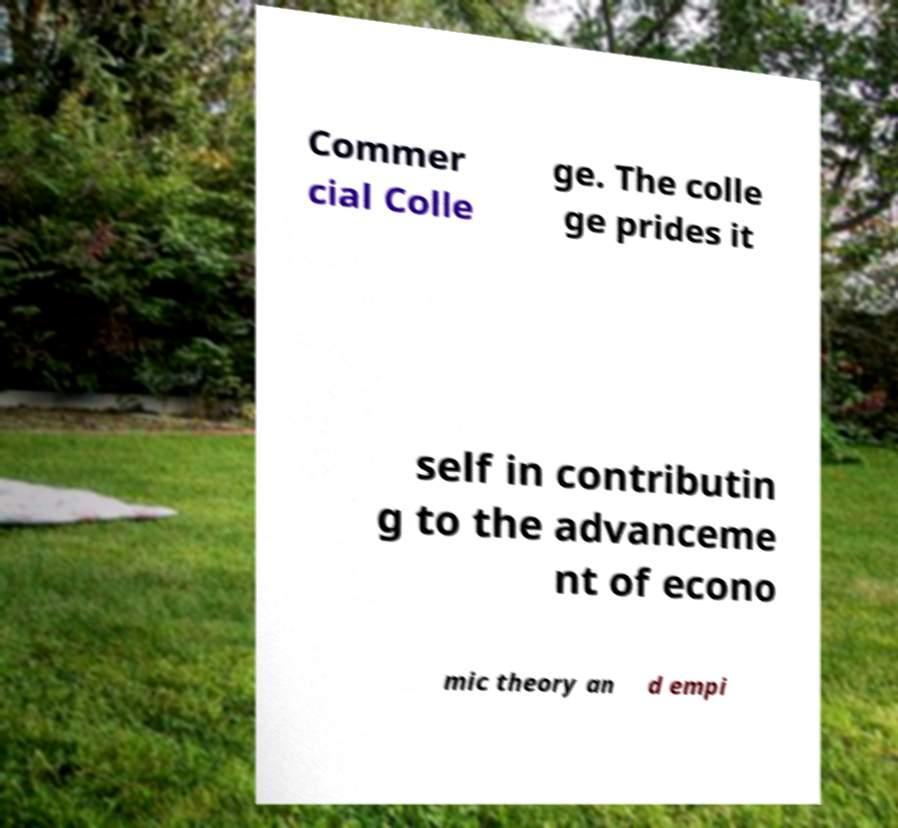I need the written content from this picture converted into text. Can you do that? Commer cial Colle ge. The colle ge prides it self in contributin g to the advanceme nt of econo mic theory an d empi 